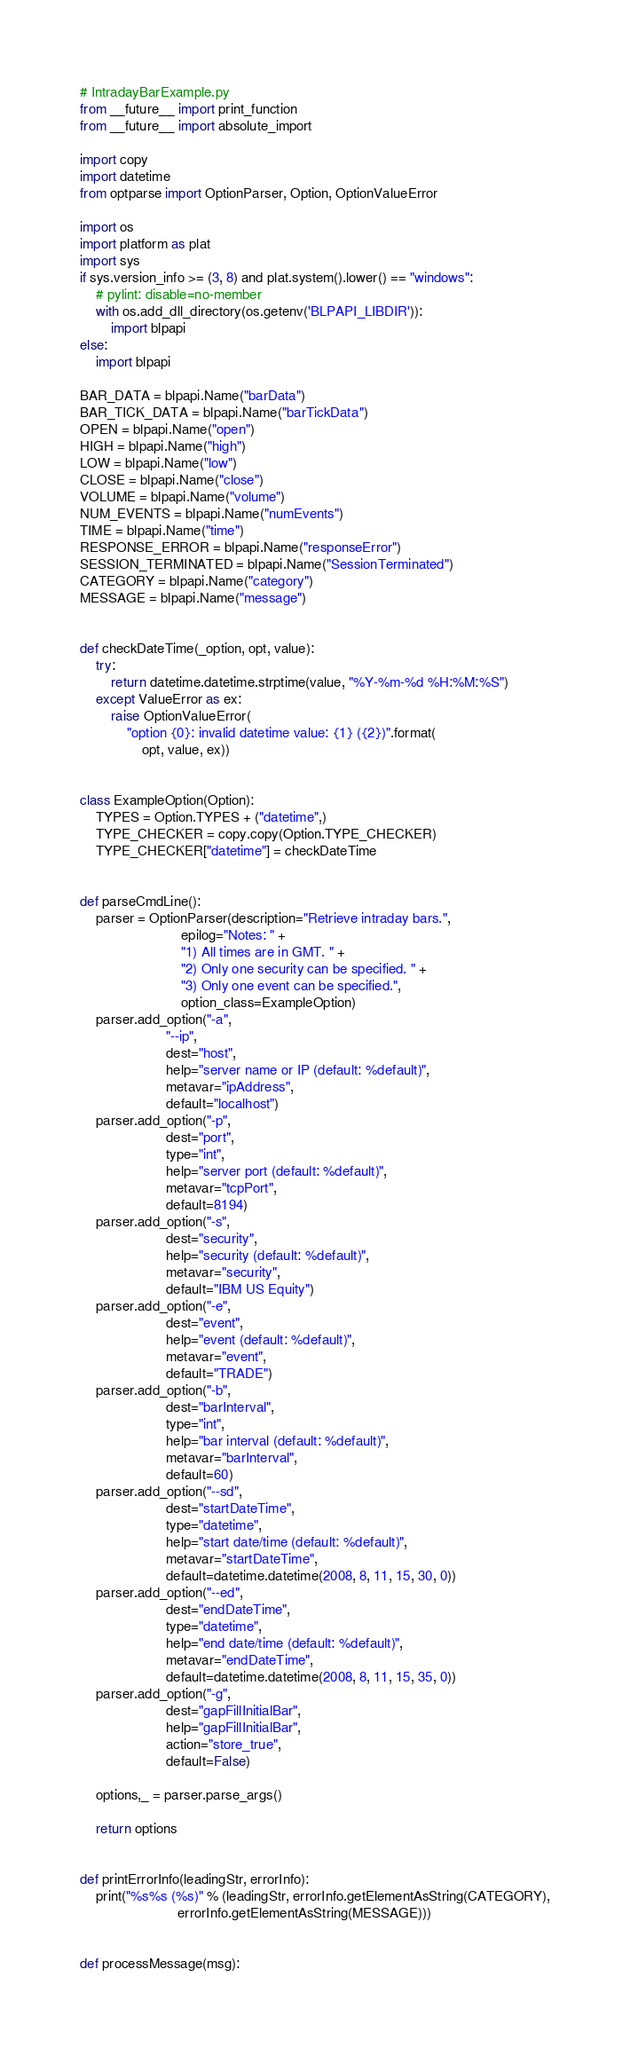<code> <loc_0><loc_0><loc_500><loc_500><_Python_># IntradayBarExample.py
from __future__ import print_function
from __future__ import absolute_import

import copy
import datetime
from optparse import OptionParser, Option, OptionValueError

import os
import platform as plat
import sys
if sys.version_info >= (3, 8) and plat.system().lower() == "windows":
    # pylint: disable=no-member
    with os.add_dll_directory(os.getenv('BLPAPI_LIBDIR')):
        import blpapi
else:
    import blpapi

BAR_DATA = blpapi.Name("barData")
BAR_TICK_DATA = blpapi.Name("barTickData")
OPEN = blpapi.Name("open")
HIGH = blpapi.Name("high")
LOW = blpapi.Name("low")
CLOSE = blpapi.Name("close")
VOLUME = blpapi.Name("volume")
NUM_EVENTS = blpapi.Name("numEvents")
TIME = blpapi.Name("time")
RESPONSE_ERROR = blpapi.Name("responseError")
SESSION_TERMINATED = blpapi.Name("SessionTerminated")
CATEGORY = blpapi.Name("category")
MESSAGE = blpapi.Name("message")


def checkDateTime(_option, opt, value):
    try:
        return datetime.datetime.strptime(value, "%Y-%m-%d %H:%M:%S")
    except ValueError as ex:
        raise OptionValueError(
            "option {0}: invalid datetime value: {1} ({2})".format(
                opt, value, ex))


class ExampleOption(Option):
    TYPES = Option.TYPES + ("datetime",)
    TYPE_CHECKER = copy.copy(Option.TYPE_CHECKER)
    TYPE_CHECKER["datetime"] = checkDateTime


def parseCmdLine():
    parser = OptionParser(description="Retrieve intraday bars.",
                          epilog="Notes: " +
                          "1) All times are in GMT. " +
                          "2) Only one security can be specified. " +
                          "3) Only one event can be specified.",
                          option_class=ExampleOption)
    parser.add_option("-a",
                      "--ip",
                      dest="host",
                      help="server name or IP (default: %default)",
                      metavar="ipAddress",
                      default="localhost")
    parser.add_option("-p",
                      dest="port",
                      type="int",
                      help="server port (default: %default)",
                      metavar="tcpPort",
                      default=8194)
    parser.add_option("-s",
                      dest="security",
                      help="security (default: %default)",
                      metavar="security",
                      default="IBM US Equity")
    parser.add_option("-e",
                      dest="event",
                      help="event (default: %default)",
                      metavar="event",
                      default="TRADE")
    parser.add_option("-b",
                      dest="barInterval",
                      type="int",
                      help="bar interval (default: %default)",
                      metavar="barInterval",
                      default=60)
    parser.add_option("--sd",
                      dest="startDateTime",
                      type="datetime",
                      help="start date/time (default: %default)",
                      metavar="startDateTime",
                      default=datetime.datetime(2008, 8, 11, 15, 30, 0))
    parser.add_option("--ed",
                      dest="endDateTime",
                      type="datetime",
                      help="end date/time (default: %default)",
                      metavar="endDateTime",
                      default=datetime.datetime(2008, 8, 11, 15, 35, 0))
    parser.add_option("-g",
                      dest="gapFillInitialBar",
                      help="gapFillInitialBar",
                      action="store_true",
                      default=False)

    options,_ = parser.parse_args()

    return options


def printErrorInfo(leadingStr, errorInfo):
    print("%s%s (%s)" % (leadingStr, errorInfo.getElementAsString(CATEGORY),
                         errorInfo.getElementAsString(MESSAGE)))


def processMessage(msg):</code> 